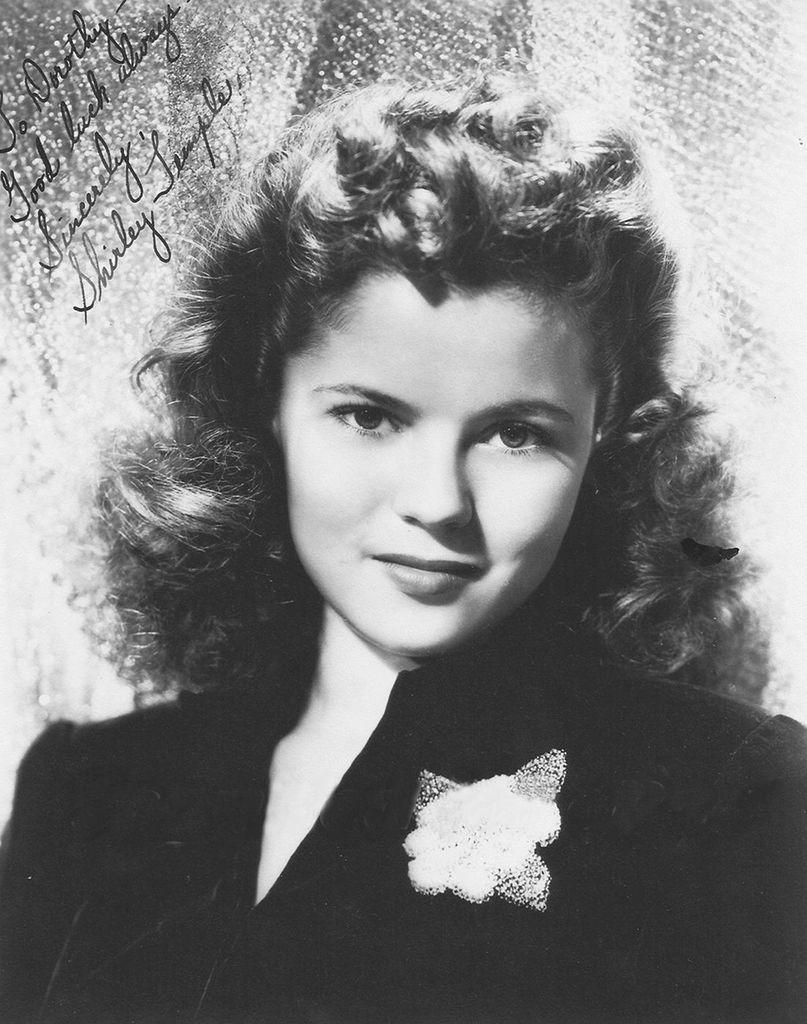Who is present in the image? There is a woman in the image. What can be seen in the top left corner of the image? There is text in the top left corner of the image. What color scheme is used in the image? The image is black and white in color. What type of art can be seen bursting out of the woman's head in the image? There is no art or bursting depicted in the image; it is a black and white photograph of a woman with text in the top left corner. 